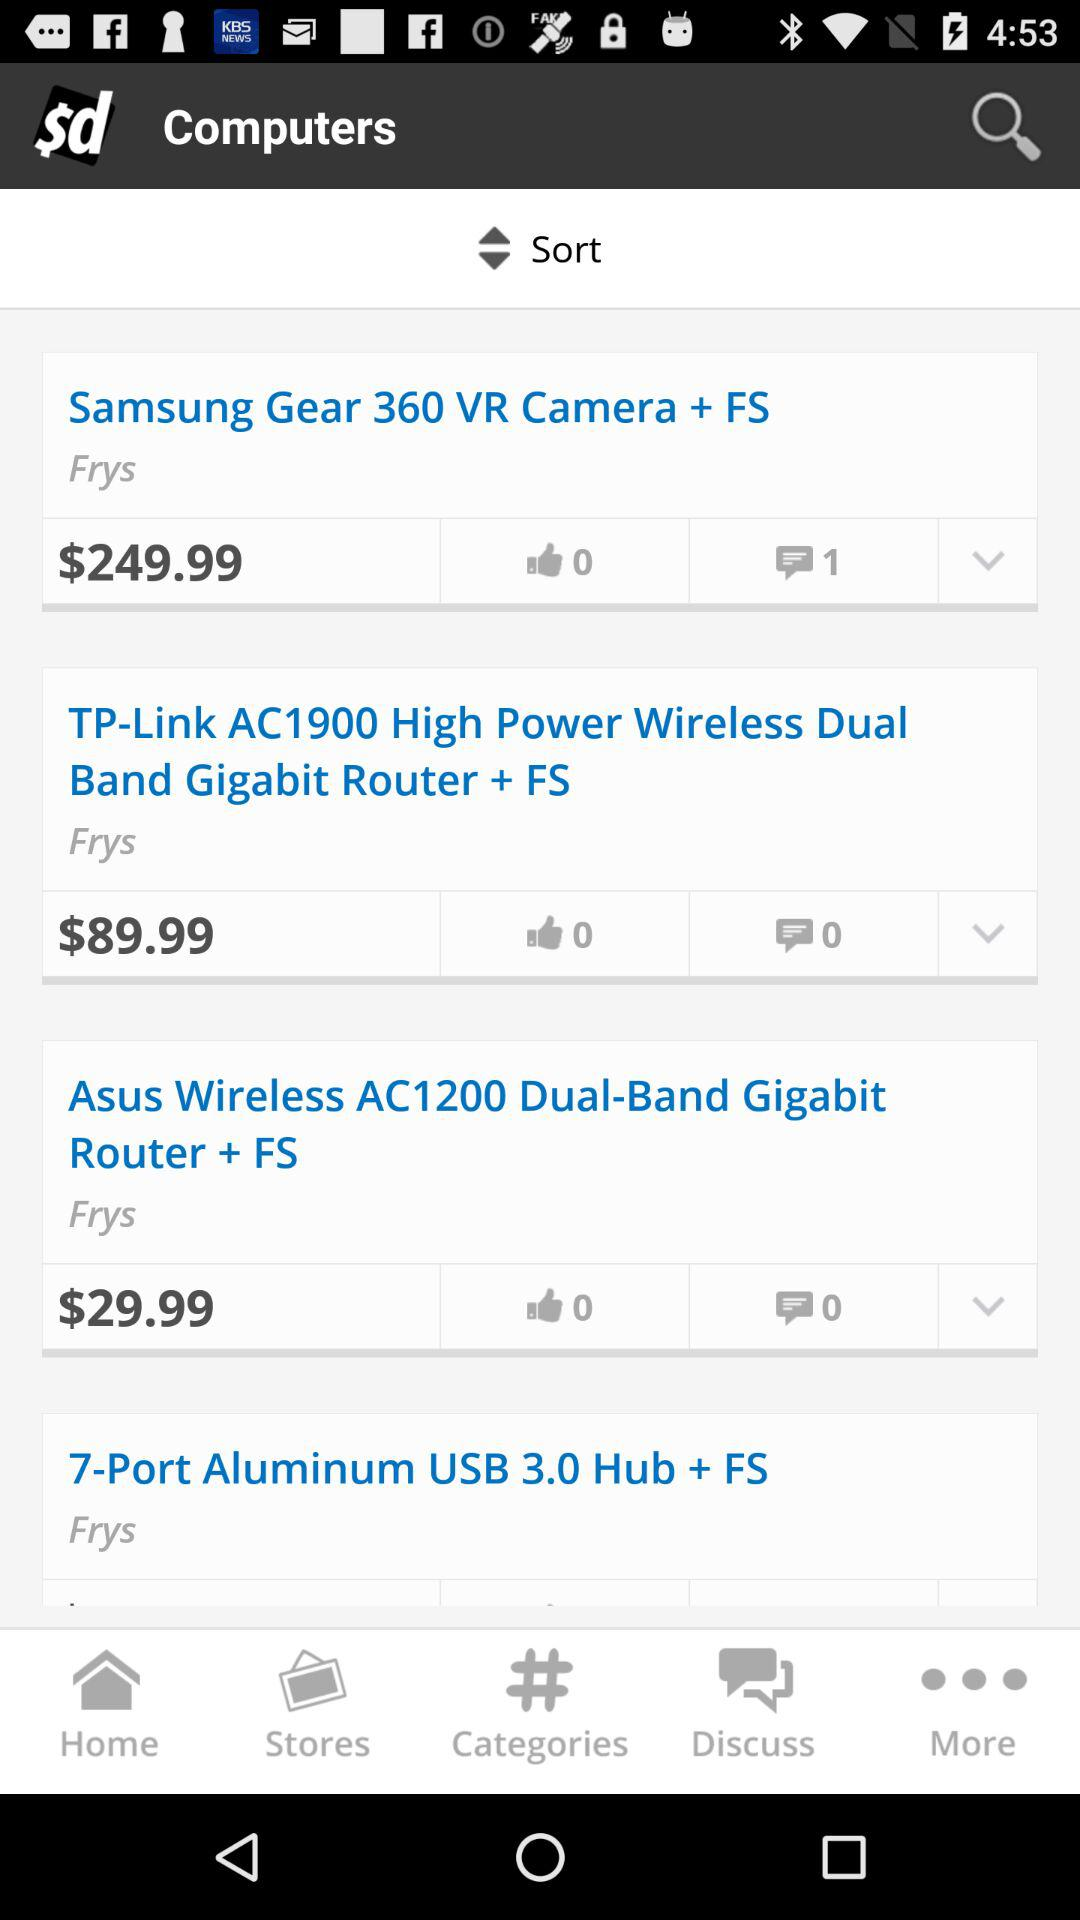How many notifications are there in "Discuss"?
When the provided information is insufficient, respond with <no answer>. <no answer> 